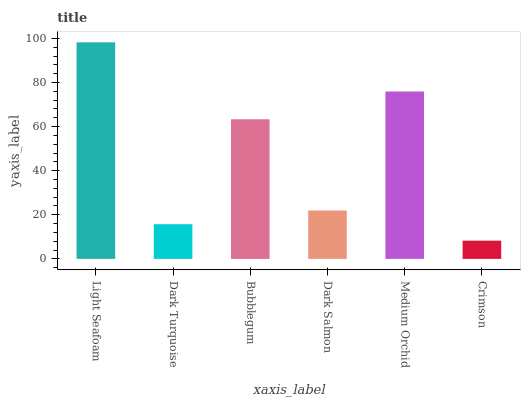Is Crimson the minimum?
Answer yes or no. Yes. Is Light Seafoam the maximum?
Answer yes or no. Yes. Is Dark Turquoise the minimum?
Answer yes or no. No. Is Dark Turquoise the maximum?
Answer yes or no. No. Is Light Seafoam greater than Dark Turquoise?
Answer yes or no. Yes. Is Dark Turquoise less than Light Seafoam?
Answer yes or no. Yes. Is Dark Turquoise greater than Light Seafoam?
Answer yes or no. No. Is Light Seafoam less than Dark Turquoise?
Answer yes or no. No. Is Bubblegum the high median?
Answer yes or no. Yes. Is Dark Salmon the low median?
Answer yes or no. Yes. Is Light Seafoam the high median?
Answer yes or no. No. Is Medium Orchid the low median?
Answer yes or no. No. 